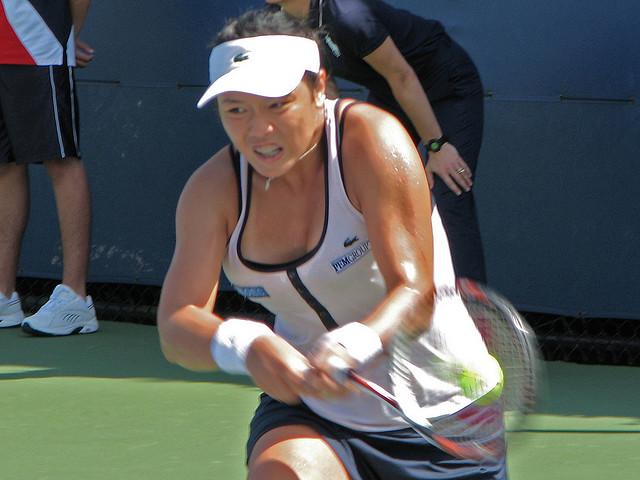Which sport is this?
Write a very short answer. Tennis. Would this woman be considered Caucasian?
Give a very brief answer. No. What is the woman doing with the racket?
Keep it brief. Swinging. 